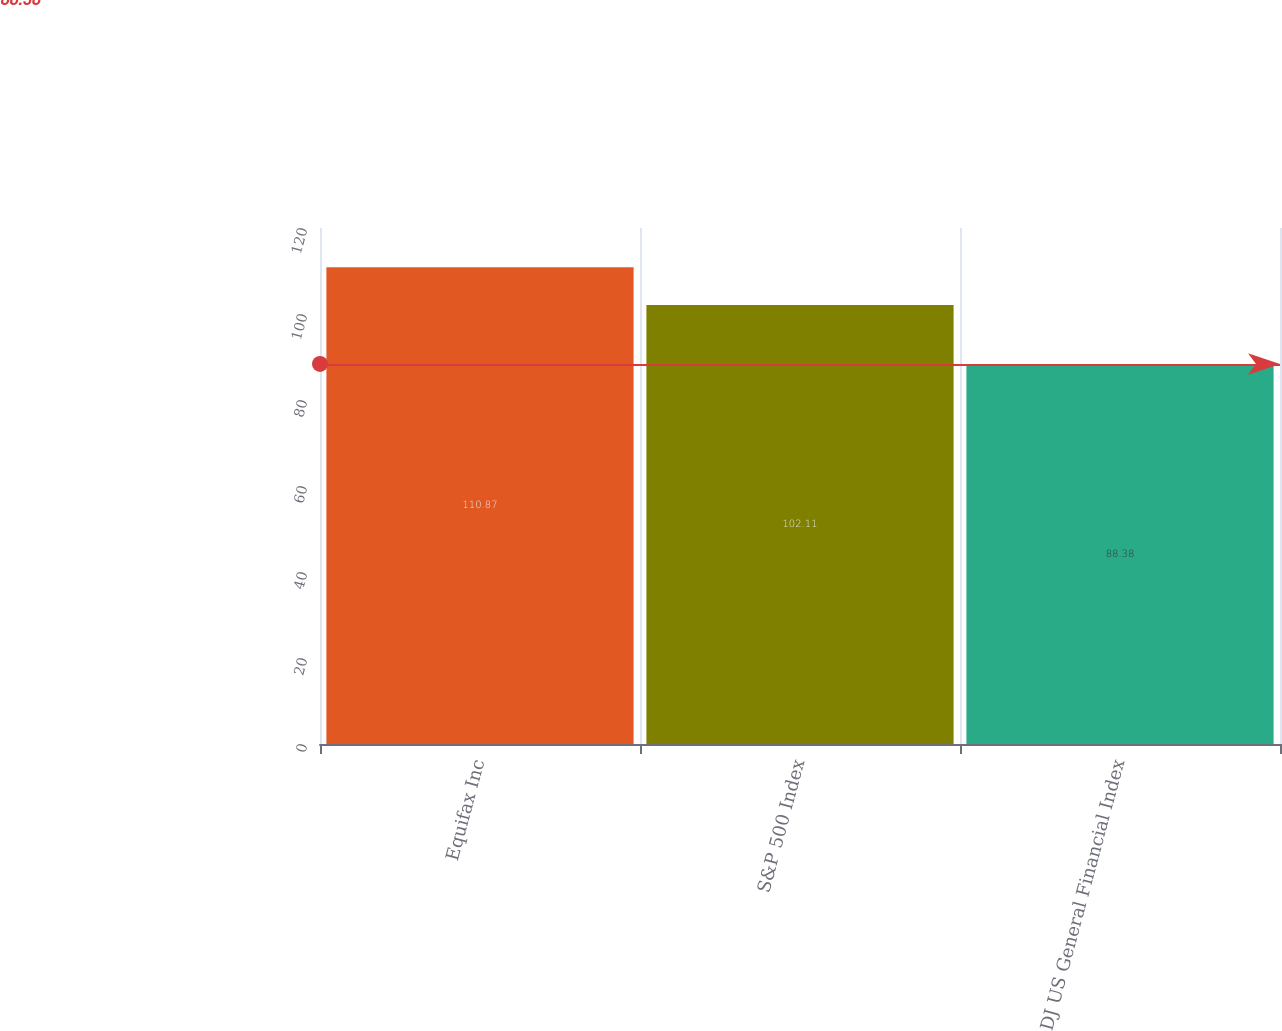Convert chart. <chart><loc_0><loc_0><loc_500><loc_500><bar_chart><fcel>Equifax Inc<fcel>S&P 500 Index<fcel>DJ US General Financial Index<nl><fcel>110.87<fcel>102.11<fcel>88.38<nl></chart> 